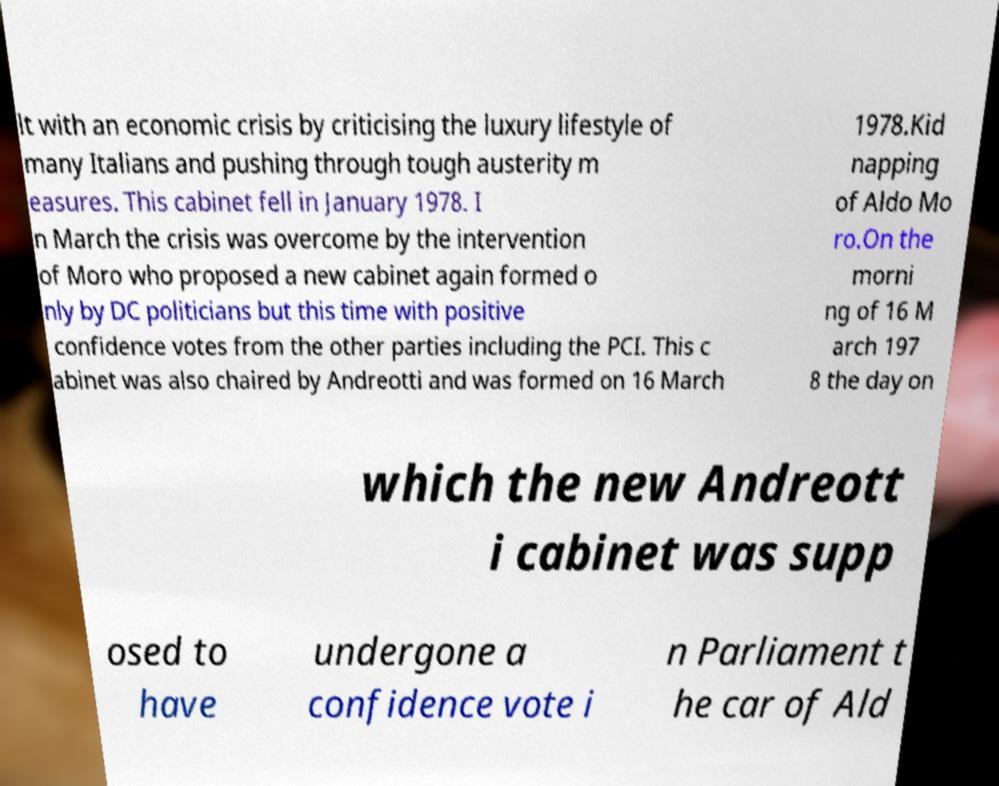I need the written content from this picture converted into text. Can you do that? lt with an economic crisis by criticising the luxury lifestyle of many Italians and pushing through tough austerity m easures. This cabinet fell in January 1978. I n March the crisis was overcome by the intervention of Moro who proposed a new cabinet again formed o nly by DC politicians but this time with positive confidence votes from the other parties including the PCI. This c abinet was also chaired by Andreotti and was formed on 16 March 1978.Kid napping of Aldo Mo ro.On the morni ng of 16 M arch 197 8 the day on which the new Andreott i cabinet was supp osed to have undergone a confidence vote i n Parliament t he car of Ald 